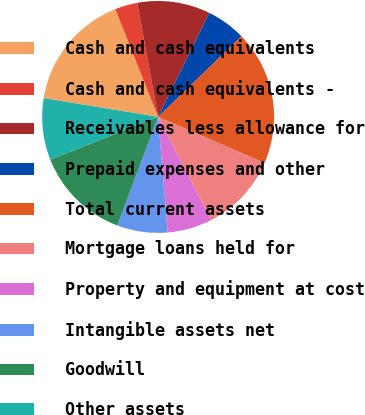Convert chart to OTSL. <chart><loc_0><loc_0><loc_500><loc_500><pie_chart><fcel>Cash and cash equivalents<fcel>Cash and cash equivalents -<fcel>Receivables less allowance for<fcel>Prepaid expenses and other<fcel>Total current assets<fcel>Mortgage loans held for<fcel>Property and equipment at cost<fcel>Intangible assets net<fcel>Goodwill<fcel>Other assets<nl><fcel>16.4%<fcel>3.13%<fcel>10.16%<fcel>5.47%<fcel>18.75%<fcel>10.94%<fcel>6.25%<fcel>7.03%<fcel>13.28%<fcel>8.59%<nl></chart> 